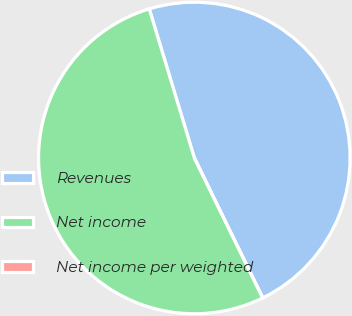Convert chart to OTSL. <chart><loc_0><loc_0><loc_500><loc_500><pie_chart><fcel>Revenues<fcel>Net income<fcel>Net income per weighted<nl><fcel>47.44%<fcel>52.56%<fcel>0.0%<nl></chart> 